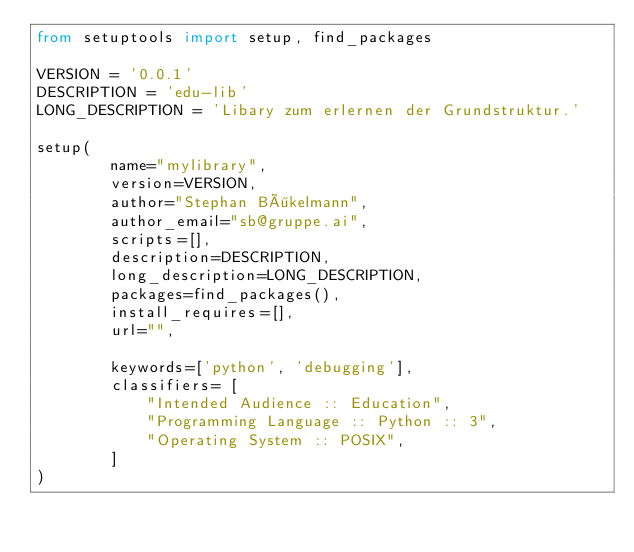<code> <loc_0><loc_0><loc_500><loc_500><_Python_>from setuptools import setup, find_packages

VERSION = '0.0.1' 
DESCRIPTION = 'edu-lib'
LONG_DESCRIPTION = 'Libary zum erlernen der Grundstruktur.'

setup(
        name="mylibrary", 
        version=VERSION,
        author="Stephan Bökelmann",
        author_email="sb@gruppe.ai",
        scripts=[],
        description=DESCRIPTION,
        long_description=LONG_DESCRIPTION,
        packages=find_packages(),
        install_requires=[], 
        url="",
        
        keywords=['python', 'debugging'],
        classifiers= [
            "Intended Audience :: Education",
            "Programming Language :: Python :: 3",
            "Operating System :: POSIX",
        ]
)
</code> 